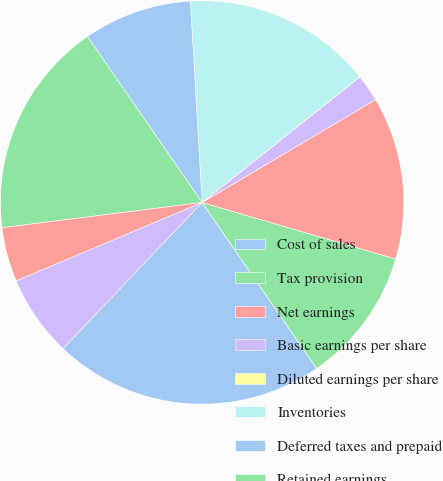Convert chart. <chart><loc_0><loc_0><loc_500><loc_500><pie_chart><fcel>Cost of sales<fcel>Tax provision<fcel>Net earnings<fcel>Basic earnings per share<fcel>Diluted earnings per share<fcel>Inventories<fcel>Deferred taxes and prepaid<fcel>Retained earnings<fcel>Deferred taxes<fcel>Inventory working capital<nl><fcel>21.72%<fcel>10.87%<fcel>13.04%<fcel>2.18%<fcel>0.01%<fcel>15.21%<fcel>8.7%<fcel>17.38%<fcel>4.36%<fcel>6.53%<nl></chart> 